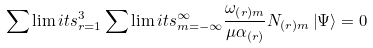<formula> <loc_0><loc_0><loc_500><loc_500>\sum \lim i t s _ { r = 1 } ^ { 3 } \sum \lim i t s _ { m = - \infty } ^ { \infty } \frac { \omega _ { \left ( r \right ) m } } { \mu \alpha _ { \left ( r \right ) } } N _ { \left ( r \right ) m } \left | \Psi \right \rangle = 0</formula> 